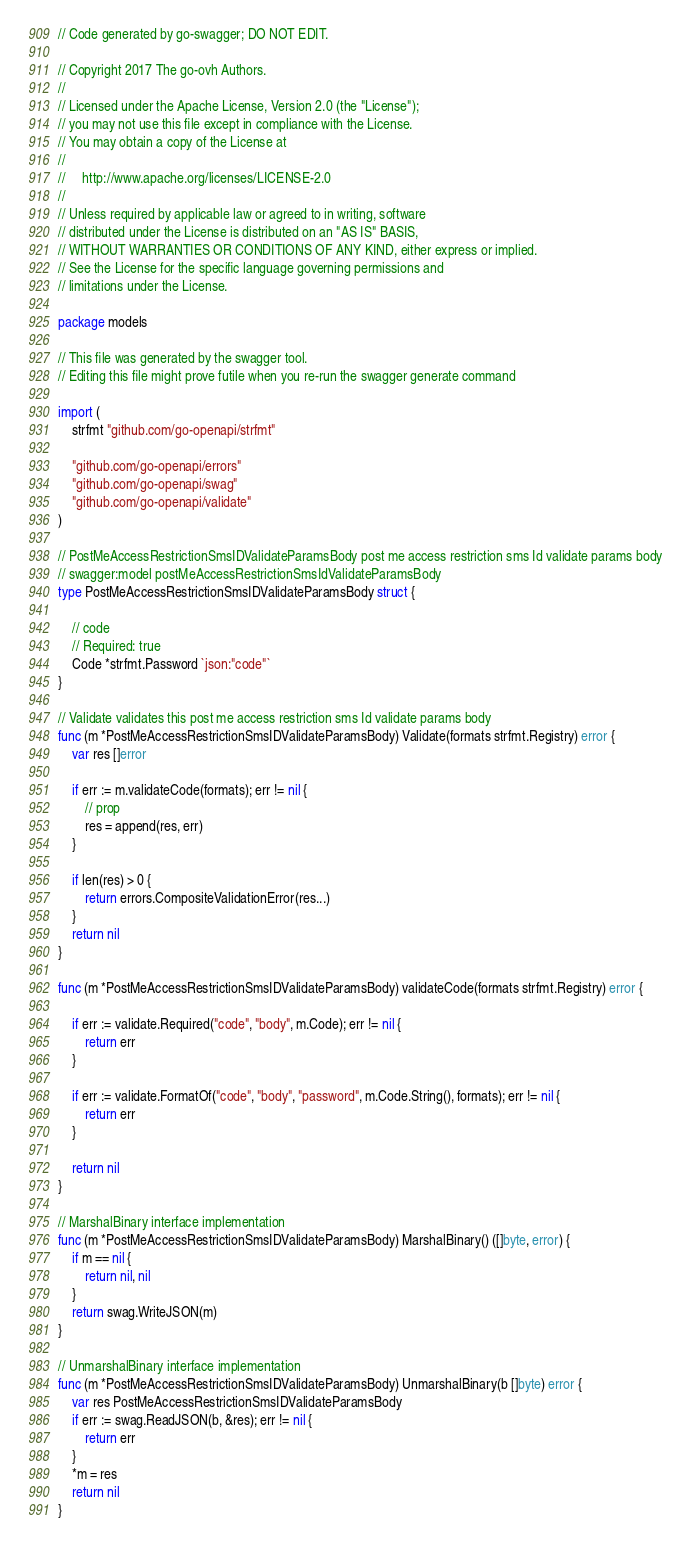<code> <loc_0><loc_0><loc_500><loc_500><_Go_>// Code generated by go-swagger; DO NOT EDIT.

// Copyright 2017 The go-ovh Authors.
//
// Licensed under the Apache License, Version 2.0 (the "License");
// you may not use this file except in compliance with the License.
// You may obtain a copy of the License at
//
//     http://www.apache.org/licenses/LICENSE-2.0
//
// Unless required by applicable law or agreed to in writing, software
// distributed under the License is distributed on an "AS IS" BASIS,
// WITHOUT WARRANTIES OR CONDITIONS OF ANY KIND, either express or implied.
// See the License for the specific language governing permissions and
// limitations under the License.

package models

// This file was generated by the swagger tool.
// Editing this file might prove futile when you re-run the swagger generate command

import (
	strfmt "github.com/go-openapi/strfmt"

	"github.com/go-openapi/errors"
	"github.com/go-openapi/swag"
	"github.com/go-openapi/validate"
)

// PostMeAccessRestrictionSmsIDValidateParamsBody post me access restriction sms Id validate params body
// swagger:model postMeAccessRestrictionSmsIdValidateParamsBody
type PostMeAccessRestrictionSmsIDValidateParamsBody struct {

	// code
	// Required: true
	Code *strfmt.Password `json:"code"`
}

// Validate validates this post me access restriction sms Id validate params body
func (m *PostMeAccessRestrictionSmsIDValidateParamsBody) Validate(formats strfmt.Registry) error {
	var res []error

	if err := m.validateCode(formats); err != nil {
		// prop
		res = append(res, err)
	}

	if len(res) > 0 {
		return errors.CompositeValidationError(res...)
	}
	return nil
}

func (m *PostMeAccessRestrictionSmsIDValidateParamsBody) validateCode(formats strfmt.Registry) error {

	if err := validate.Required("code", "body", m.Code); err != nil {
		return err
	}

	if err := validate.FormatOf("code", "body", "password", m.Code.String(), formats); err != nil {
		return err
	}

	return nil
}

// MarshalBinary interface implementation
func (m *PostMeAccessRestrictionSmsIDValidateParamsBody) MarshalBinary() ([]byte, error) {
	if m == nil {
		return nil, nil
	}
	return swag.WriteJSON(m)
}

// UnmarshalBinary interface implementation
func (m *PostMeAccessRestrictionSmsIDValidateParamsBody) UnmarshalBinary(b []byte) error {
	var res PostMeAccessRestrictionSmsIDValidateParamsBody
	if err := swag.ReadJSON(b, &res); err != nil {
		return err
	}
	*m = res
	return nil
}
</code> 